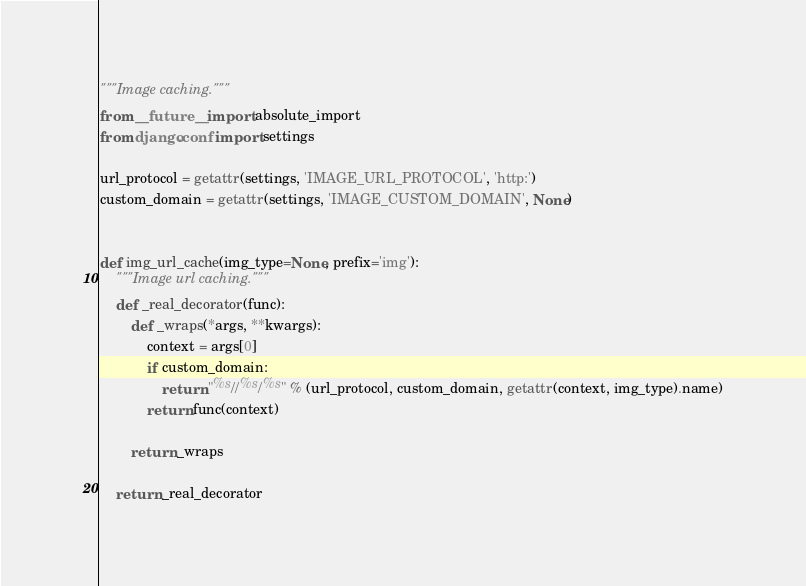<code> <loc_0><loc_0><loc_500><loc_500><_Python_>"""Image caching."""
from __future__ import absolute_import
from django.conf import settings

url_protocol = getattr(settings, 'IMAGE_URL_PROTOCOL', 'http:')
custom_domain = getattr(settings, 'IMAGE_CUSTOM_DOMAIN', None)


def img_url_cache(img_type=None, prefix='img'):
    """Image url caching."""
    def _real_decorator(func):
        def _wraps(*args, **kwargs):
            context = args[0]
            if custom_domain:
                return "%s//%s/%s" % (url_protocol, custom_domain, getattr(context, img_type).name)
            return func(context)

        return _wraps

    return _real_decorator
</code> 